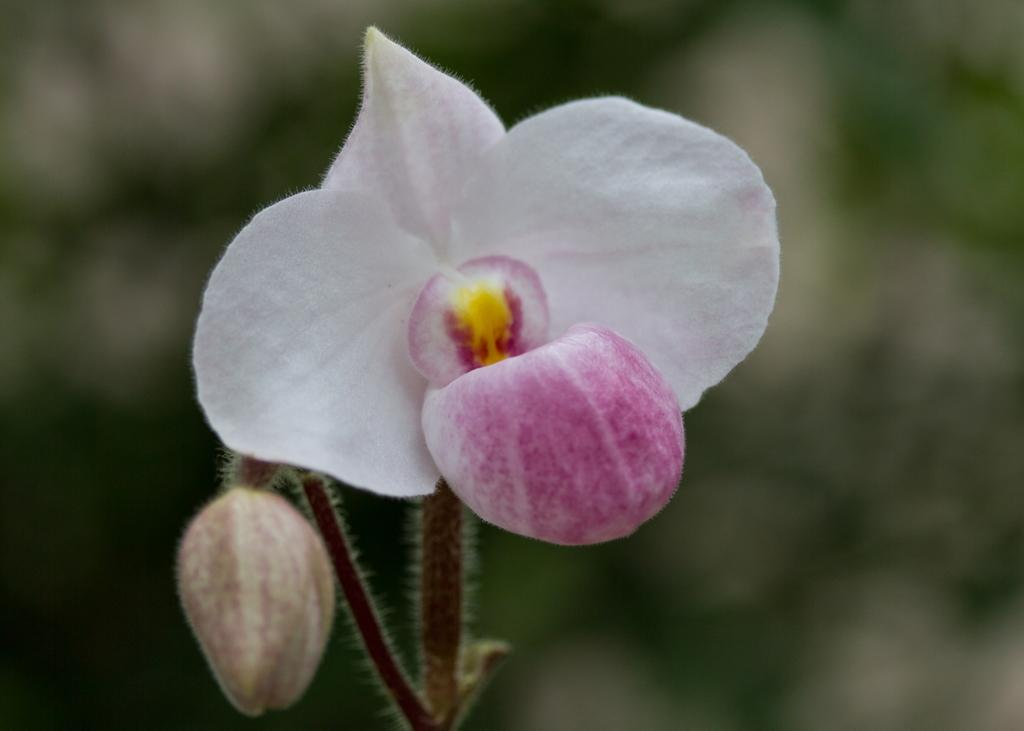What is the main subject of the image? There is a flower in the image. Can you describe any specific features of the flower? There is a bud on the stem of the flower. What can be observed about the background of the image? The background of the image is blurred. What type of watch can be seen on the stem of the flower in the image? There is no watch present on the stem of the flower in the image. How many marbles are visible in the image? There are no marbles present in the image; it features a flower with a bud on the stem. 